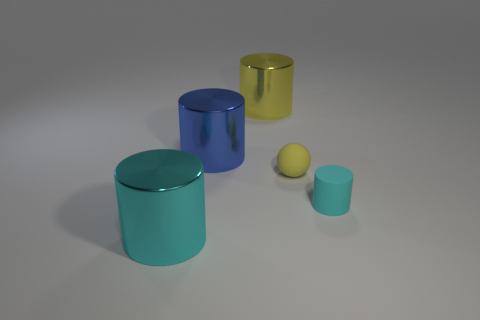Does the big cyan cylinder have the same material as the blue object?
Your answer should be very brief. Yes. There is a cyan object that is on the left side of the cylinder right of the big yellow metal cylinder; are there any large metallic cylinders that are right of it?
Provide a succinct answer. Yes. How many other objects are there of the same shape as the large blue thing?
Offer a very short reply. 3. There is a thing that is both in front of the tiny yellow rubber ball and to the left of the small yellow thing; what is its shape?
Provide a short and direct response. Cylinder. What is the color of the small matte object that is on the right side of the matte object that is behind the cyan object that is to the right of the cyan metal thing?
Your response must be concise. Cyan. Is the number of cyan things that are left of the yellow matte thing greater than the number of small cyan things that are left of the matte cylinder?
Keep it short and to the point. Yes. What number of other objects are the same size as the cyan metallic cylinder?
Your answer should be compact. 2. There is a cyan object on the left side of the metal object right of the blue object; what is its material?
Ensure brevity in your answer.  Metal. There is a small yellow sphere; are there any large cyan cylinders left of it?
Your answer should be compact. Yes. Are there more blue cylinders to the left of the big yellow cylinder than small matte objects?
Your answer should be compact. No. 